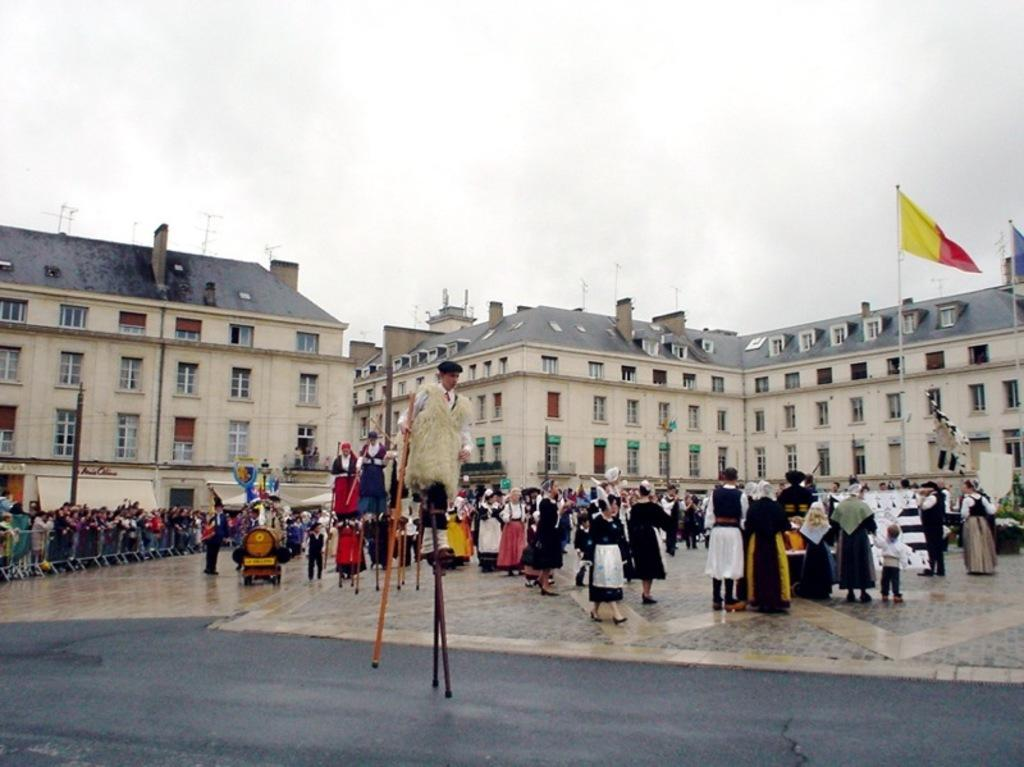What are the people in the image doing? There are persons standing on the floor in the image, and one person is walking on sticks. What can be seen in the background of the image? There are buildings, flags, flag posts, chimneys, and the sky visible in the background of the image. What type of lock is used to secure the territory in the image? There is no mention of a territory or a lock in the image. The image features persons standing on the floor, a person walking on sticks, and various background elements. 